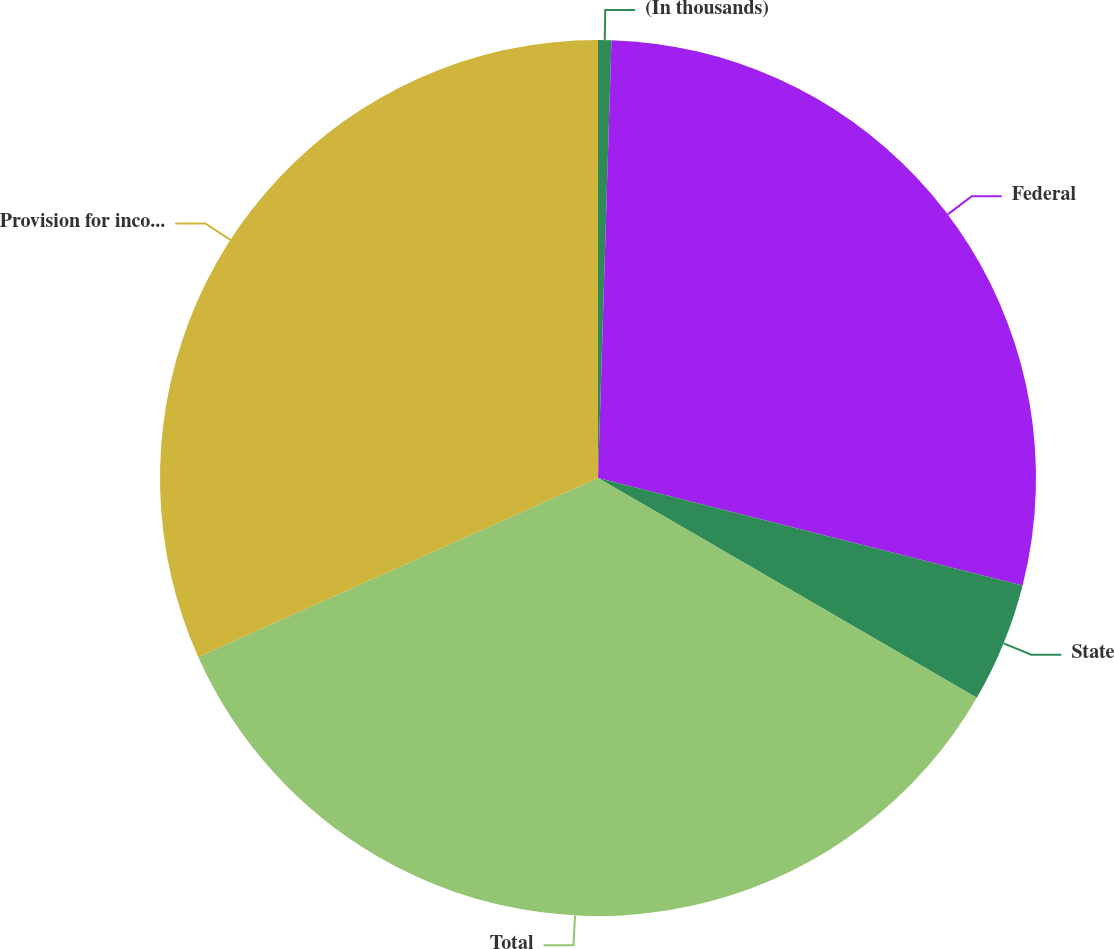<chart> <loc_0><loc_0><loc_500><loc_500><pie_chart><fcel>(In thousands)<fcel>Federal<fcel>State<fcel>Total<fcel>Provision for income taxes<nl><fcel>0.49%<fcel>28.46%<fcel>4.42%<fcel>34.93%<fcel>31.7%<nl></chart> 